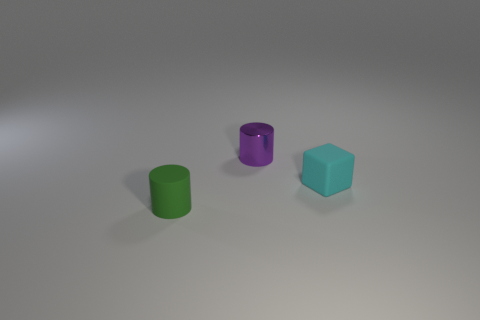Does the cylinder that is behind the small green matte cylinder have the same material as the cylinder in front of the tiny cyan block?
Your answer should be very brief. No. How many metallic cylinders are behind the tiny cylinder that is in front of the cyan thing?
Make the answer very short. 1. Is the shape of the metallic object right of the tiny matte cylinder the same as the rubber thing that is on the left side of the small block?
Offer a very short reply. Yes. What is the color of the metallic thing that is the same shape as the green rubber thing?
Keep it short and to the point. Purple. What is the color of the tiny rubber block on the right side of the rubber object that is on the left side of the purple shiny cylinder?
Offer a terse response. Cyan. There is a purple object; what shape is it?
Offer a terse response. Cylinder. There is a small thing that is both left of the tiny cyan block and on the right side of the green cylinder; what is its shape?
Ensure brevity in your answer.  Cylinder. There is a cylinder that is the same material as the cyan block; what color is it?
Make the answer very short. Green. There is a tiny object on the left side of the cylinder that is behind the cyan rubber thing that is right of the purple shiny object; what is its shape?
Offer a very short reply. Cylinder. What is the size of the cyan object?
Keep it short and to the point. Small. 